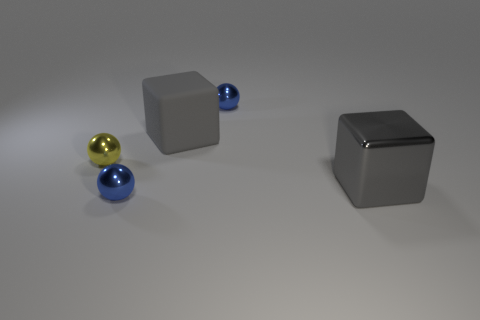How many cubes are gray metallic objects or gray rubber objects?
Give a very brief answer. 2. What number of small blue balls are there?
Offer a very short reply. 2. What is the size of the blue object that is behind the blue metallic object that is in front of the gray shiny thing?
Provide a short and direct response. Small. What number of other objects are the same size as the matte block?
Make the answer very short. 1. What number of gray rubber objects are to the right of the tiny yellow metallic ball?
Offer a terse response. 1. The metallic block is what size?
Ensure brevity in your answer.  Large. Does the small blue ball that is in front of the big metal cube have the same material as the blue sphere that is behind the gray metallic object?
Keep it short and to the point. Yes. Are there any large things of the same color as the metallic block?
Provide a succinct answer. Yes. The other block that is the same size as the gray rubber cube is what color?
Offer a very short reply. Gray. Do the big cube behind the shiny block and the metallic cube have the same color?
Offer a very short reply. Yes. 